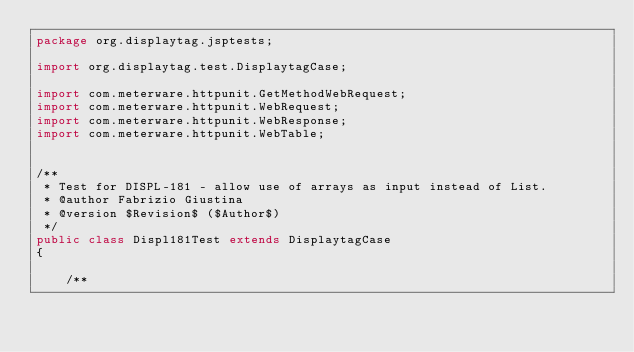<code> <loc_0><loc_0><loc_500><loc_500><_Java_>package org.displaytag.jsptests;

import org.displaytag.test.DisplaytagCase;

import com.meterware.httpunit.GetMethodWebRequest;
import com.meterware.httpunit.WebRequest;
import com.meterware.httpunit.WebResponse;
import com.meterware.httpunit.WebTable;


/**
 * Test for DISPL-181 - allow use of arrays as input instead of List.
 * @author Fabrizio Giustina
 * @version $Revision$ ($Author$)
 */
public class Displ181Test extends DisplaytagCase
{

    /**</code> 